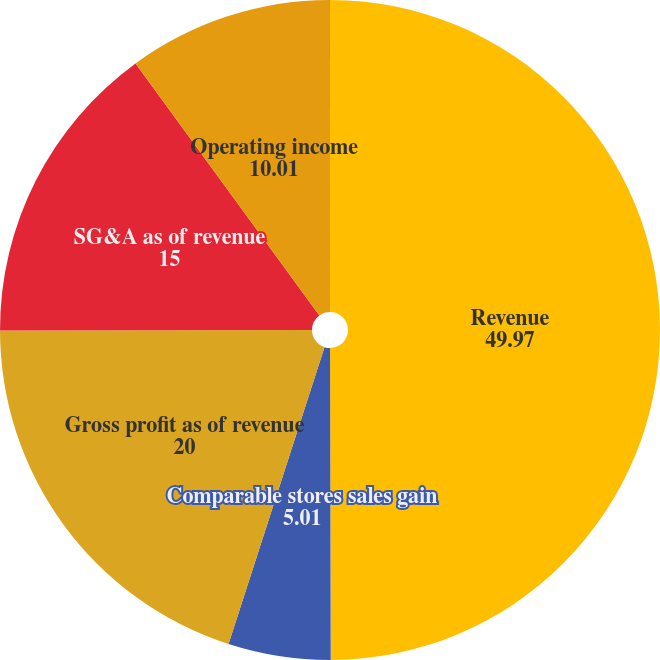<chart> <loc_0><loc_0><loc_500><loc_500><pie_chart><fcel>Revenue<fcel>Comparable stores sales gain<fcel>Gross profit as of revenue<fcel>SG&A as of revenue<fcel>Operating income<fcel>Operating income as of revenue<nl><fcel>49.97%<fcel>5.01%<fcel>20.0%<fcel>15.0%<fcel>10.01%<fcel>0.02%<nl></chart> 